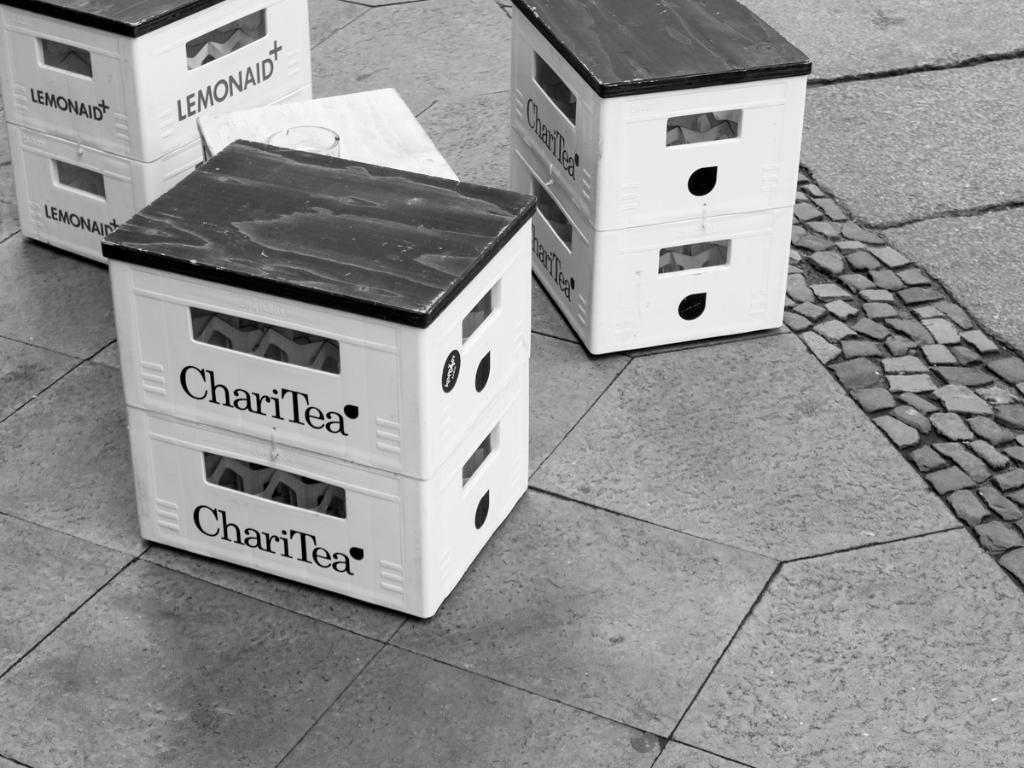<image>
Offer a succinct explanation of the picture presented. Crates of Chari Tea and Lemonaid sit on the sidewalk. 